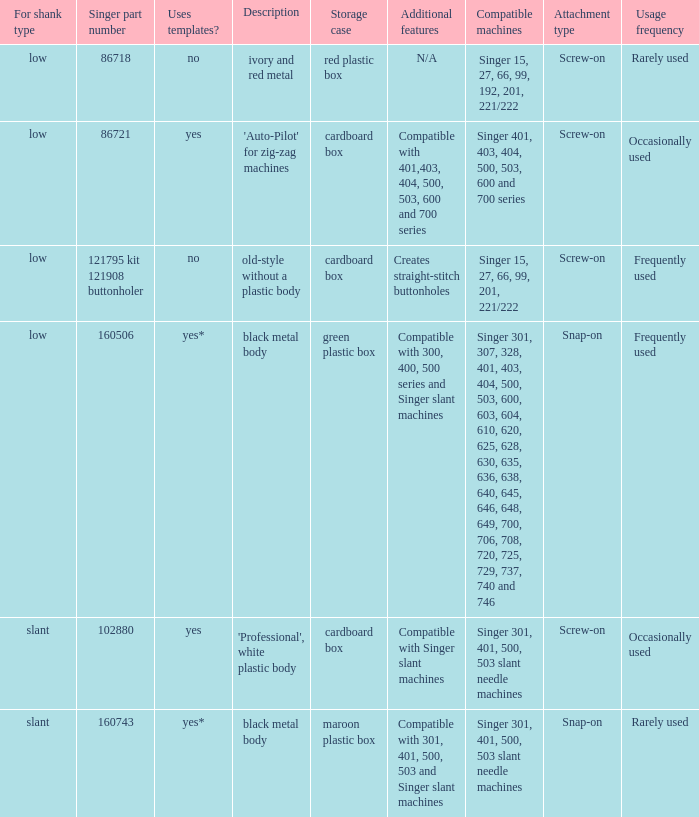What's the shank type of the buttonholer with red plastic box as storage case? Low. 